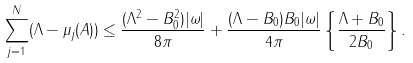<formula> <loc_0><loc_0><loc_500><loc_500>\sum _ { j = 1 } ^ { N } ( \Lambda - \mu _ { j } ( A ) ) \leq \frac { ( \Lambda ^ { 2 } - B _ { 0 } ^ { 2 } ) | \omega | } { 8 \pi } + \frac { ( \Lambda - B _ { 0 } ) B _ { 0 } | \omega | } { 4 \pi } \left \{ \frac { \Lambda + B _ { 0 } } { 2 B _ { 0 } } \right \} .</formula> 